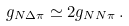Convert formula to latex. <formula><loc_0><loc_0><loc_500><loc_500>g _ { N \Delta \pi } \simeq 2 g _ { N N \pi } \, .</formula> 